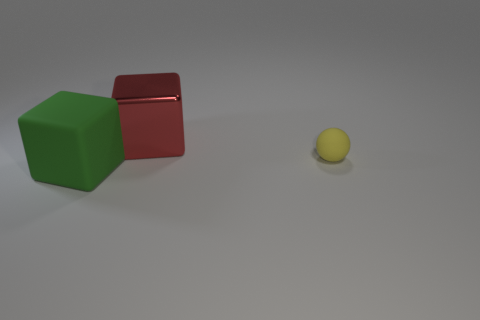What size is the rubber thing behind the big cube that is to the left of the big block that is behind the small yellow sphere?
Provide a succinct answer. Small. There is a object that is behind the small yellow rubber sphere; does it have the same color as the big rubber thing?
Your response must be concise. No. There is a matte thing that is the same shape as the large metallic object; what size is it?
Offer a terse response. Large. How many things are objects behind the yellow ball or blocks that are right of the big matte thing?
Your response must be concise. 1. What shape is the matte object that is to the right of the cube that is in front of the large red object?
Make the answer very short. Sphere. Are there any other things that have the same color as the large metallic thing?
Your answer should be very brief. No. Is there any other thing that is the same size as the yellow rubber sphere?
Your response must be concise. No. What number of things are metallic objects or tiny green cylinders?
Give a very brief answer. 1. Are there any matte balls of the same size as the rubber cube?
Offer a terse response. No. The small yellow object has what shape?
Your response must be concise. Sphere. 